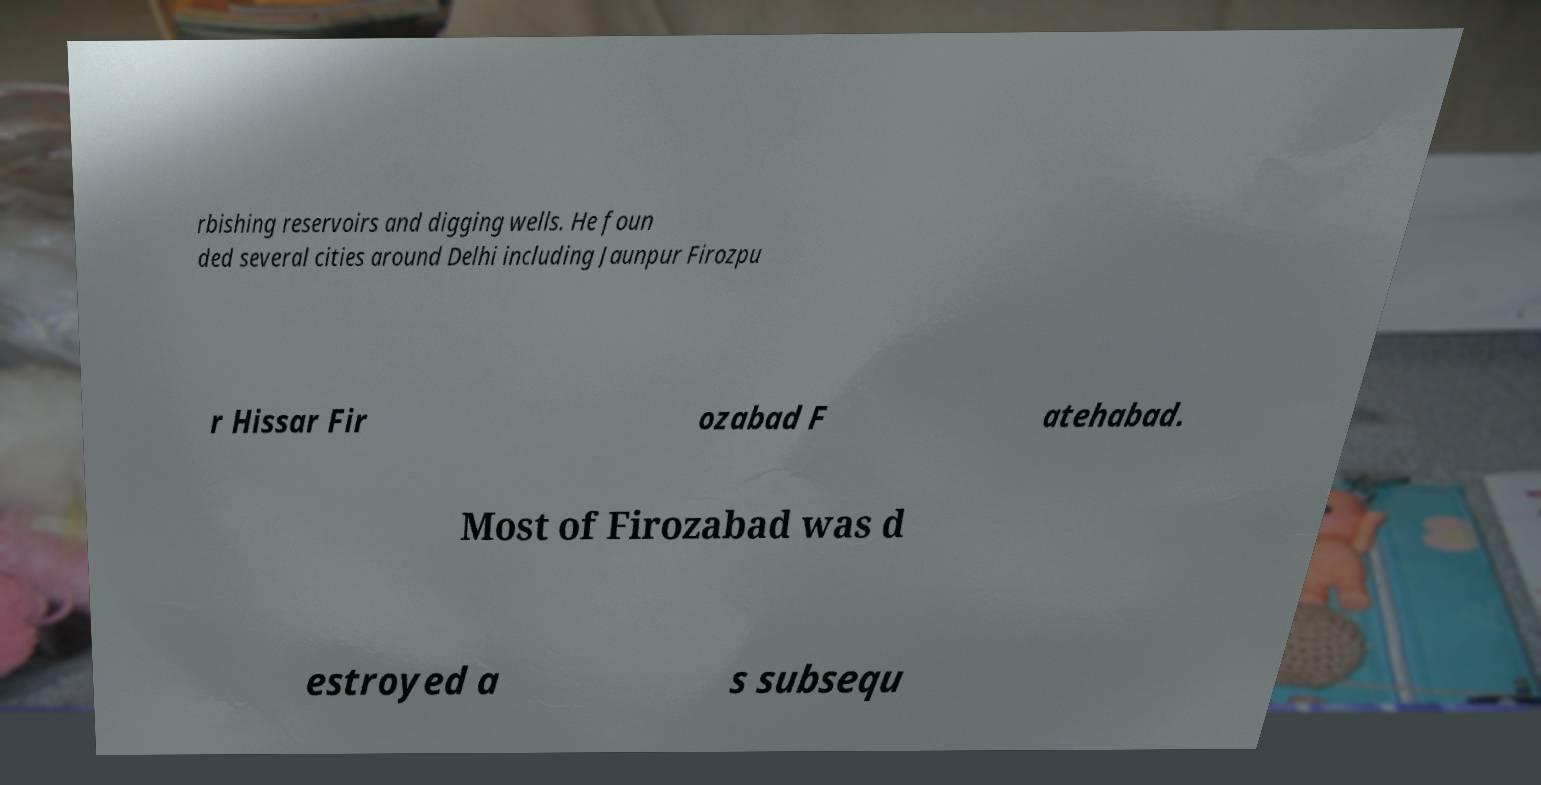Can you read and provide the text displayed in the image?This photo seems to have some interesting text. Can you extract and type it out for me? rbishing reservoirs and digging wells. He foun ded several cities around Delhi including Jaunpur Firozpu r Hissar Fir ozabad F atehabad. Most of Firozabad was d estroyed a s subsequ 